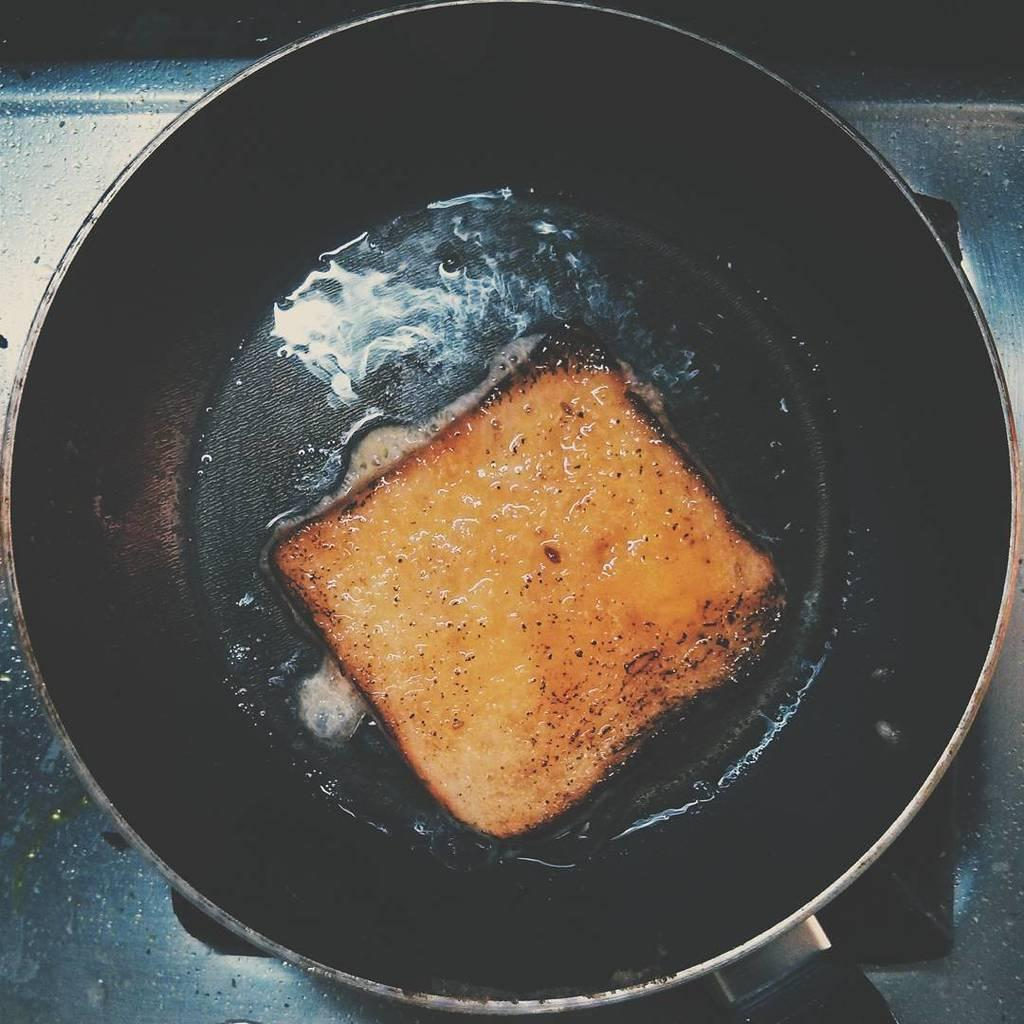What is the main object in the image? There is a frying pan in the image. What is inside the frying pan? There is bread in the frying pan. What can be seen in the background of the image? There is a metal object that looks like a stove in the background of the image. How many ladybugs are crawling on the bread in the image? There are no ladybugs present in the image; it only features a frying pan with bread and a metal object that looks like a stove in the background. 